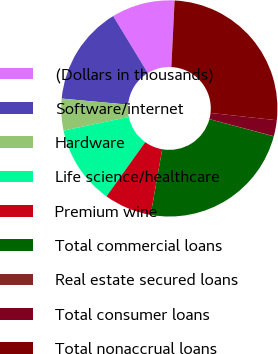<chart> <loc_0><loc_0><loc_500><loc_500><pie_chart><fcel>(Dollars in thousands)<fcel>Software/internet<fcel>Hardware<fcel>Life science/healthcare<fcel>Premium wine<fcel>Total commercial loans<fcel>Real estate secured loans<fcel>Total consumer loans<fcel>Total nonaccrual loans<nl><fcel>9.47%<fcel>14.85%<fcel>4.75%<fcel>11.83%<fcel>7.11%<fcel>23.61%<fcel>0.03%<fcel>2.39%<fcel>25.97%<nl></chart> 